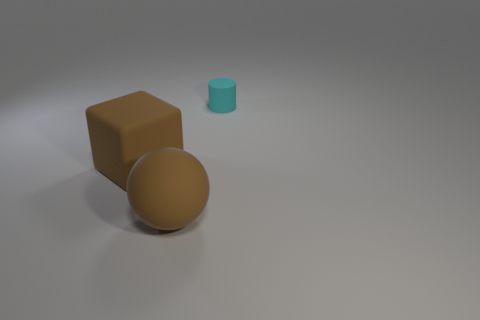Add 3 blue metal cylinders. How many objects exist? 6 Subtract all spheres. How many objects are left? 2 Subtract 0 blue blocks. How many objects are left? 3 Subtract all brown blocks. Subtract all large brown blocks. How many objects are left? 1 Add 3 cylinders. How many cylinders are left? 4 Add 2 cylinders. How many cylinders exist? 3 